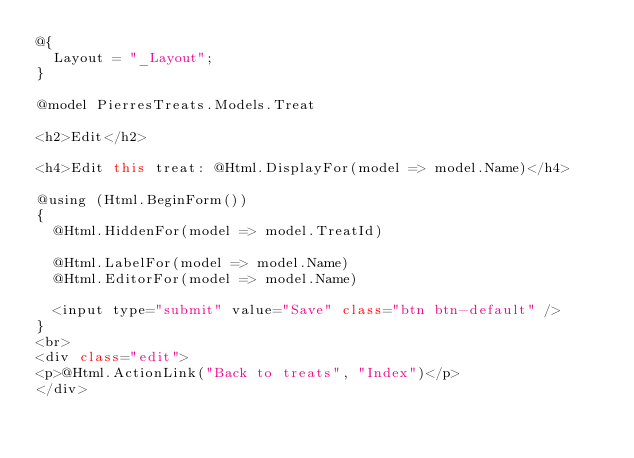Convert code to text. <code><loc_0><loc_0><loc_500><loc_500><_C#_>@{
  Layout = "_Layout";
}

@model PierresTreats.Models.Treat

<h2>Edit</h2>

<h4>Edit this treat: @Html.DisplayFor(model => model.Name)</h4>

@using (Html.BeginForm())
{
  @Html.HiddenFor(model => model.TreatId)

  @Html.LabelFor(model => model.Name)
  @Html.EditorFor(model => model.Name)

  <input type="submit" value="Save" class="btn btn-default" />
}
<br>
<div class="edit">
<p>@Html.ActionLink("Back to treats", "Index")</p>
</div></code> 